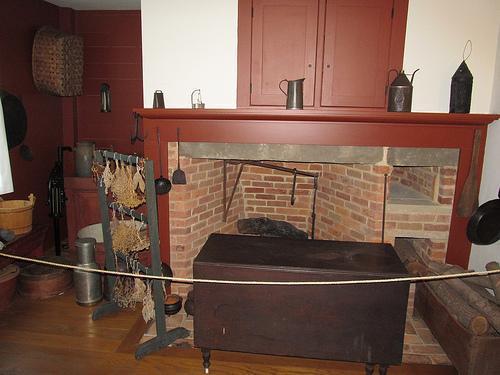How many fireplaces are there?
Give a very brief answer. 1. 